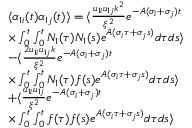Convert formula to latex. <formula><loc_0><loc_0><loc_500><loc_500>\begin{array} { r l } & { \langle \alpha _ { 1 i } ( t ) \alpha _ { 1 j } ( t ) \rangle = \langle \frac { u _ { 1 i } u _ { 1 j } k ^ { 2 } } { \xi ^ { 2 } } e ^ { - A ( \sigma _ { i } + \sigma _ { j } ) t } } \\ & { \times \int _ { 0 } ^ { t } \int _ { 0 } ^ { t } N _ { 1 } ( \tau ) N _ { 1 } ( s ) e ^ { A ( \sigma _ { i } \tau + \sigma _ { j } s ) } d \tau d s \rangle } \\ & { - \langle \frac { 2 u _ { 1 i } u _ { 1 j } k } { \xi ^ { 2 } } e ^ { - A ( \sigma _ { i } + \sigma _ { j } ) t } } \\ & { \times \int _ { 0 } ^ { t } \int _ { 0 } ^ { t } N _ { 1 } ( \tau ) f ( s ) e ^ { A ( \sigma _ { i } \tau + \sigma _ { j } s ) } d \tau d s \rangle } \\ & { + \langle \frac { u _ { 1 i } u _ { 1 j } } { \xi ^ { 2 } } e ^ { - A ( \sigma _ { i } + \sigma _ { j } ) t } } \\ & { \times \int _ { 0 } ^ { t } \int _ { 0 } ^ { t } f ( \tau ) f ( s ) e ^ { A ( \sigma _ { i } \tau + \sigma _ { j } s ) } d \tau d s \rangle } \end{array}</formula> 